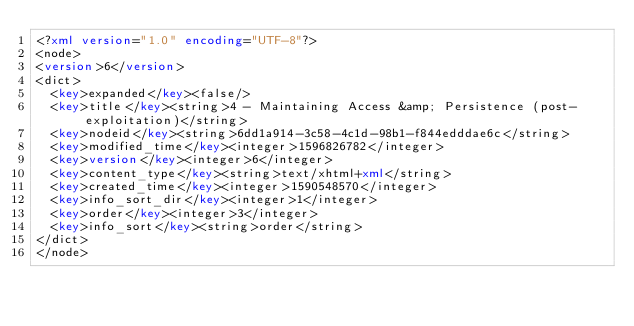<code> <loc_0><loc_0><loc_500><loc_500><_XML_><?xml version="1.0" encoding="UTF-8"?>
<node>
<version>6</version>
<dict>
  <key>expanded</key><false/>
  <key>title</key><string>4 - Maintaining Access &amp; Persistence (post-exploitation)</string>
  <key>nodeid</key><string>6dd1a914-3c58-4c1d-98b1-f844edddae6c</string>
  <key>modified_time</key><integer>1596826782</integer>
  <key>version</key><integer>6</integer>
  <key>content_type</key><string>text/xhtml+xml</string>
  <key>created_time</key><integer>1590548570</integer>
  <key>info_sort_dir</key><integer>1</integer>
  <key>order</key><integer>3</integer>
  <key>info_sort</key><string>order</string>
</dict>
</node>
</code> 